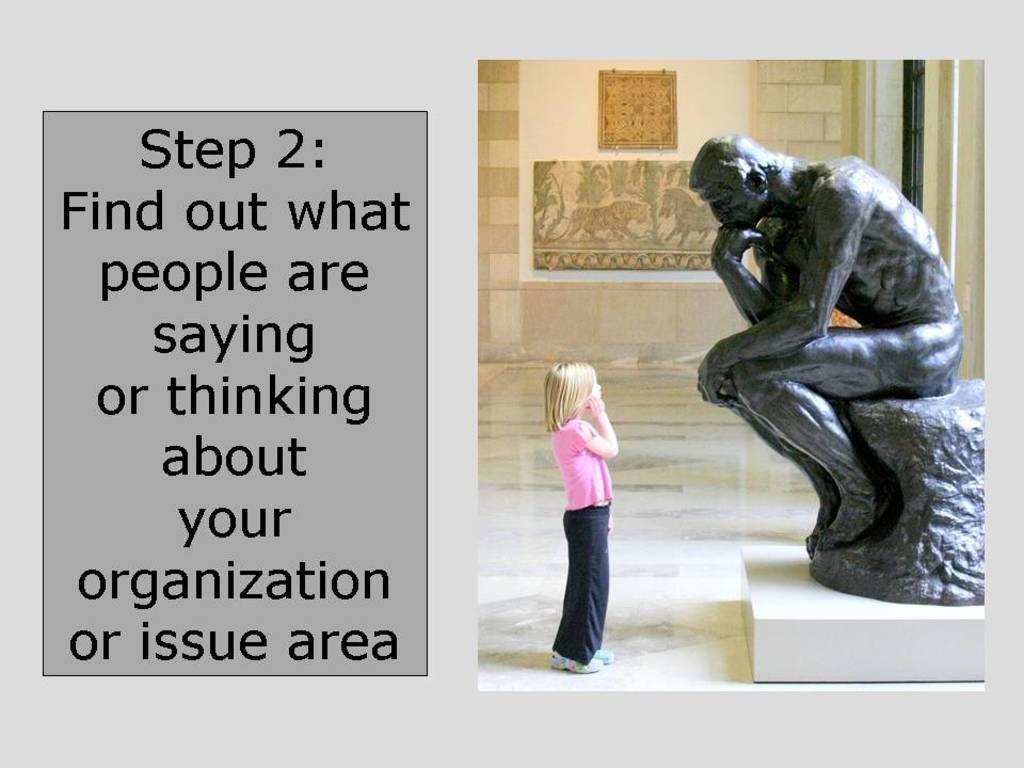How would you summarize this image in a sentence or two? In the picture we can see some words written, on right side of the picture there is a kid wearing pink color top, blue color jeans standing near the statue which is of a person and in the background of the picture there is a wall. 